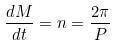<formula> <loc_0><loc_0><loc_500><loc_500>\frac { d M } { d t } = n = \frac { 2 \pi } { P }</formula> 